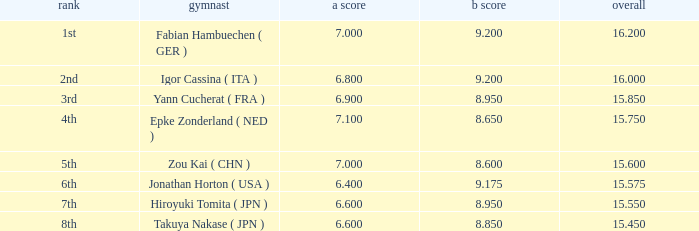Which gymnast had a b score of 8.95 and an a score less than 6.9 Hiroyuki Tomita ( JPN ). 